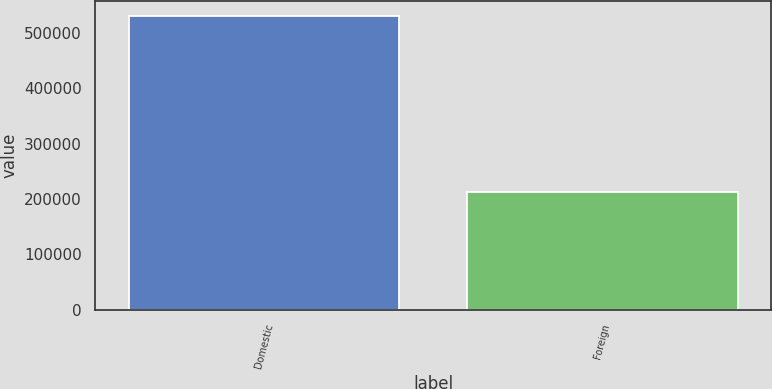Convert chart to OTSL. <chart><loc_0><loc_0><loc_500><loc_500><bar_chart><fcel>Domestic<fcel>Foreign<nl><fcel>530680<fcel>212306<nl></chart> 